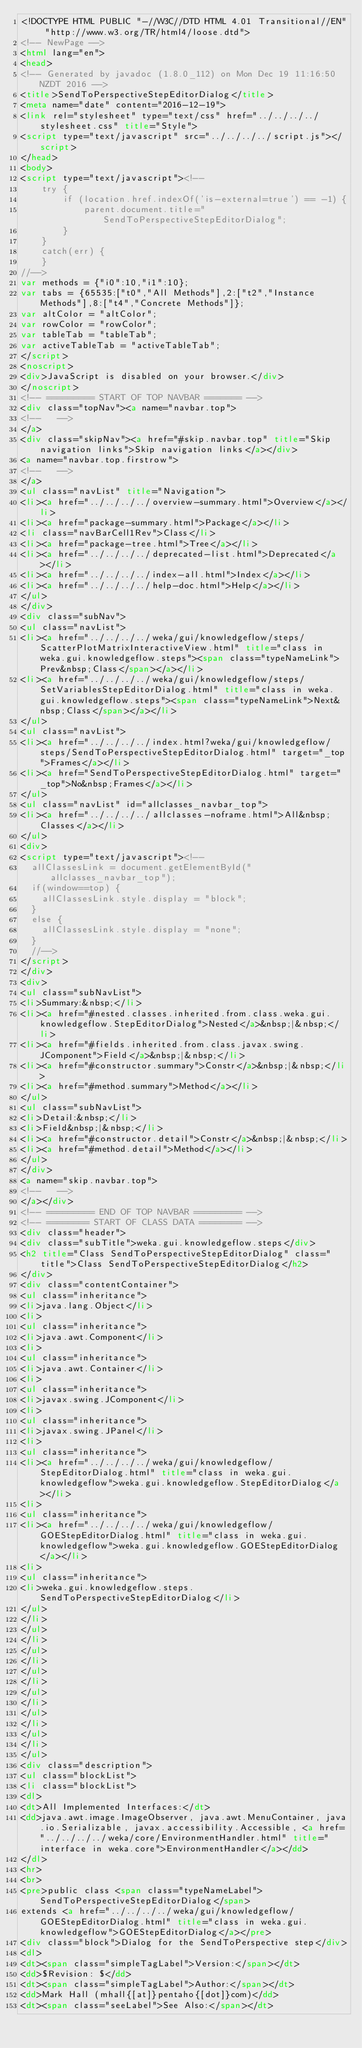<code> <loc_0><loc_0><loc_500><loc_500><_HTML_><!DOCTYPE HTML PUBLIC "-//W3C//DTD HTML 4.01 Transitional//EN" "http://www.w3.org/TR/html4/loose.dtd">
<!-- NewPage -->
<html lang="en">
<head>
<!-- Generated by javadoc (1.8.0_112) on Mon Dec 19 11:16:50 NZDT 2016 -->
<title>SendToPerspectiveStepEditorDialog</title>
<meta name="date" content="2016-12-19">
<link rel="stylesheet" type="text/css" href="../../../../stylesheet.css" title="Style">
<script type="text/javascript" src="../../../../script.js"></script>
</head>
<body>
<script type="text/javascript"><!--
    try {
        if (location.href.indexOf('is-external=true') == -1) {
            parent.document.title="SendToPerspectiveStepEditorDialog";
        }
    }
    catch(err) {
    }
//-->
var methods = {"i0":10,"i1":10};
var tabs = {65535:["t0","All Methods"],2:["t2","Instance Methods"],8:["t4","Concrete Methods"]};
var altColor = "altColor";
var rowColor = "rowColor";
var tableTab = "tableTab";
var activeTableTab = "activeTableTab";
</script>
<noscript>
<div>JavaScript is disabled on your browser.</div>
</noscript>
<!-- ========= START OF TOP NAVBAR ======= -->
<div class="topNav"><a name="navbar.top">
<!--   -->
</a>
<div class="skipNav"><a href="#skip.navbar.top" title="Skip navigation links">Skip navigation links</a></div>
<a name="navbar.top.firstrow">
<!--   -->
</a>
<ul class="navList" title="Navigation">
<li><a href="../../../../overview-summary.html">Overview</a></li>
<li><a href="package-summary.html">Package</a></li>
<li class="navBarCell1Rev">Class</li>
<li><a href="package-tree.html">Tree</a></li>
<li><a href="../../../../deprecated-list.html">Deprecated</a></li>
<li><a href="../../../../index-all.html">Index</a></li>
<li><a href="../../../../help-doc.html">Help</a></li>
</ul>
</div>
<div class="subNav">
<ul class="navList">
<li><a href="../../../../weka/gui/knowledgeflow/steps/ScatterPlotMatrixInteractiveView.html" title="class in weka.gui.knowledgeflow.steps"><span class="typeNameLink">Prev&nbsp;Class</span></a></li>
<li><a href="../../../../weka/gui/knowledgeflow/steps/SetVariablesStepEditorDialog.html" title="class in weka.gui.knowledgeflow.steps"><span class="typeNameLink">Next&nbsp;Class</span></a></li>
</ul>
<ul class="navList">
<li><a href="../../../../index.html?weka/gui/knowledgeflow/steps/SendToPerspectiveStepEditorDialog.html" target="_top">Frames</a></li>
<li><a href="SendToPerspectiveStepEditorDialog.html" target="_top">No&nbsp;Frames</a></li>
</ul>
<ul class="navList" id="allclasses_navbar_top">
<li><a href="../../../../allclasses-noframe.html">All&nbsp;Classes</a></li>
</ul>
<div>
<script type="text/javascript"><!--
  allClassesLink = document.getElementById("allclasses_navbar_top");
  if(window==top) {
    allClassesLink.style.display = "block";
  }
  else {
    allClassesLink.style.display = "none";
  }
  //-->
</script>
</div>
<div>
<ul class="subNavList">
<li>Summary:&nbsp;</li>
<li><a href="#nested.classes.inherited.from.class.weka.gui.knowledgeflow.StepEditorDialog">Nested</a>&nbsp;|&nbsp;</li>
<li><a href="#fields.inherited.from.class.javax.swing.JComponent">Field</a>&nbsp;|&nbsp;</li>
<li><a href="#constructor.summary">Constr</a>&nbsp;|&nbsp;</li>
<li><a href="#method.summary">Method</a></li>
</ul>
<ul class="subNavList">
<li>Detail:&nbsp;</li>
<li>Field&nbsp;|&nbsp;</li>
<li><a href="#constructor.detail">Constr</a>&nbsp;|&nbsp;</li>
<li><a href="#method.detail">Method</a></li>
</ul>
</div>
<a name="skip.navbar.top">
<!--   -->
</a></div>
<!-- ========= END OF TOP NAVBAR ========= -->
<!-- ======== START OF CLASS DATA ======== -->
<div class="header">
<div class="subTitle">weka.gui.knowledgeflow.steps</div>
<h2 title="Class SendToPerspectiveStepEditorDialog" class="title">Class SendToPerspectiveStepEditorDialog</h2>
</div>
<div class="contentContainer">
<ul class="inheritance">
<li>java.lang.Object</li>
<li>
<ul class="inheritance">
<li>java.awt.Component</li>
<li>
<ul class="inheritance">
<li>java.awt.Container</li>
<li>
<ul class="inheritance">
<li>javax.swing.JComponent</li>
<li>
<ul class="inheritance">
<li>javax.swing.JPanel</li>
<li>
<ul class="inheritance">
<li><a href="../../../../weka/gui/knowledgeflow/StepEditorDialog.html" title="class in weka.gui.knowledgeflow">weka.gui.knowledgeflow.StepEditorDialog</a></li>
<li>
<ul class="inheritance">
<li><a href="../../../../weka/gui/knowledgeflow/GOEStepEditorDialog.html" title="class in weka.gui.knowledgeflow">weka.gui.knowledgeflow.GOEStepEditorDialog</a></li>
<li>
<ul class="inheritance">
<li>weka.gui.knowledgeflow.steps.SendToPerspectiveStepEditorDialog</li>
</ul>
</li>
</ul>
</li>
</ul>
</li>
</ul>
</li>
</ul>
</li>
</ul>
</li>
</ul>
</li>
</ul>
<div class="description">
<ul class="blockList">
<li class="blockList">
<dl>
<dt>All Implemented Interfaces:</dt>
<dd>java.awt.image.ImageObserver, java.awt.MenuContainer, java.io.Serializable, javax.accessibility.Accessible, <a href="../../../../weka/core/EnvironmentHandler.html" title="interface in weka.core">EnvironmentHandler</a></dd>
</dl>
<hr>
<br>
<pre>public class <span class="typeNameLabel">SendToPerspectiveStepEditorDialog</span>
extends <a href="../../../../weka/gui/knowledgeflow/GOEStepEditorDialog.html" title="class in weka.gui.knowledgeflow">GOEStepEditorDialog</a></pre>
<div class="block">Dialog for the SendToPerspective step</div>
<dl>
<dt><span class="simpleTagLabel">Version:</span></dt>
<dd>$Revision: $</dd>
<dt><span class="simpleTagLabel">Author:</span></dt>
<dd>Mark Hall (mhall{[at]}pentaho{[dot]}com)</dd>
<dt><span class="seeLabel">See Also:</span></dt></code> 